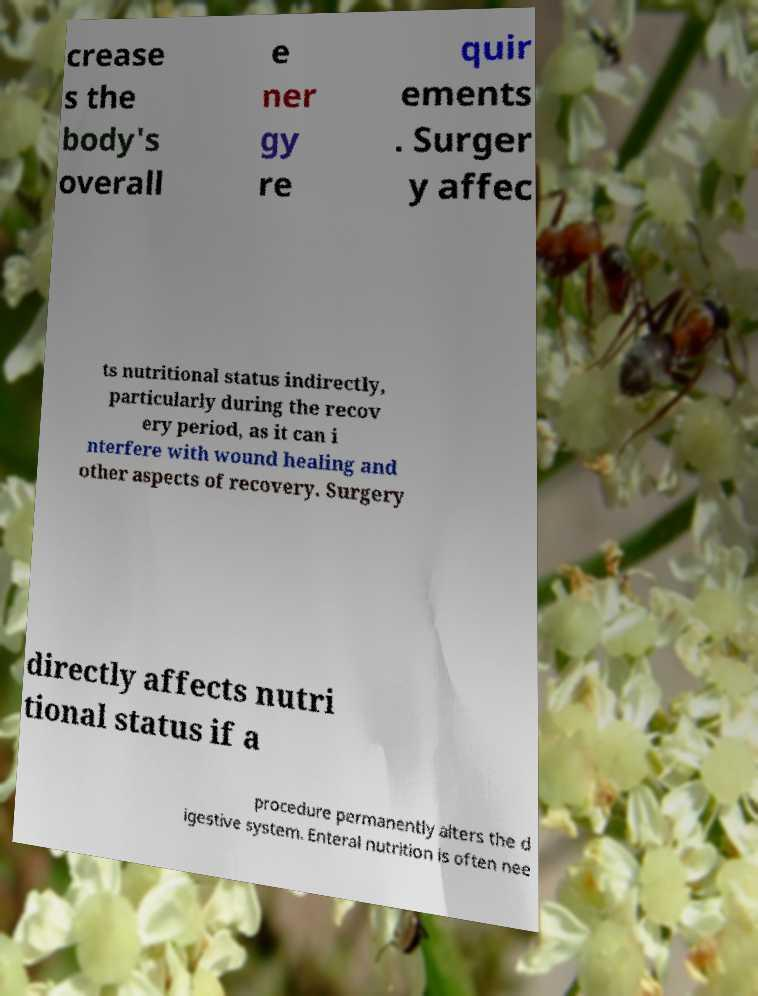Please identify and transcribe the text found in this image. crease s the body's overall e ner gy re quir ements . Surger y affec ts nutritional status indirectly, particularly during the recov ery period, as it can i nterfere with wound healing and other aspects of recovery. Surgery directly affects nutri tional status if a procedure permanently alters the d igestive system. Enteral nutrition is often nee 